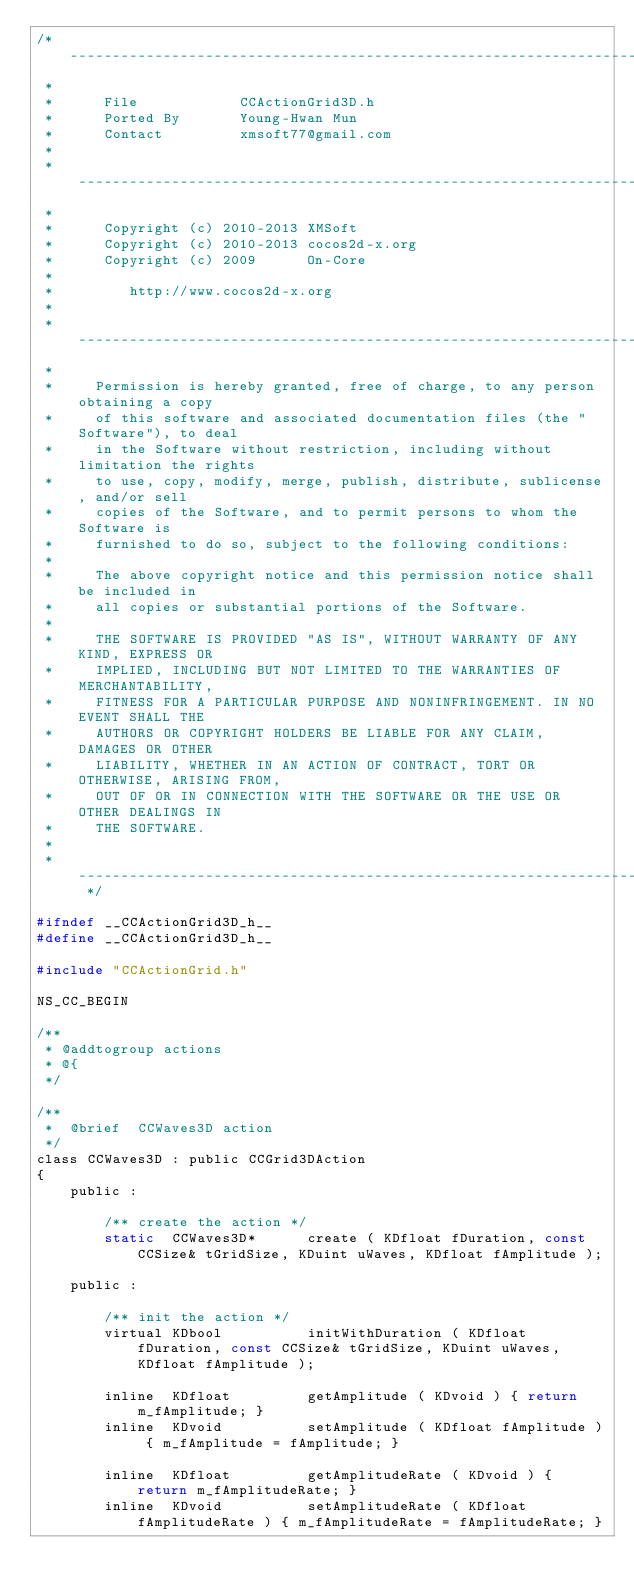Convert code to text. <code><loc_0><loc_0><loc_500><loc_500><_C_>/* -----------------------------------------------------------------------------------
 *
 *      File            CCActionGrid3D.h
 *      Ported By       Young-Hwan Mun
 *      Contact         xmsoft77@gmail.com 
 * 
 * -----------------------------------------------------------------------------------
 *   
 *      Copyright (c) 2010-2013 XMSoft
 *      Copyright (c) 2010-2013 cocos2d-x.org
 *      Copyright (c) 2009      On-Core
 *
 *         http://www.cocos2d-x.org      
 *
 * -----------------------------------------------------------------------------------
 * 
 *     Permission is hereby granted, free of charge, to any person obtaining a copy
 *     of this software and associated documentation files (the "Software"), to deal
 *     in the Software without restriction, including without limitation the rights
 *     to use, copy, modify, merge, publish, distribute, sublicense, and/or sell
 *     copies of the Software, and to permit persons to whom the Software is
 *     furnished to do so, subject to the following conditions:
 *
 *     The above copyright notice and this permission notice shall be included in
 *     all copies or substantial portions of the Software.
 *     
 *     THE SOFTWARE IS PROVIDED "AS IS", WITHOUT WARRANTY OF ANY KIND, EXPRESS OR
 *     IMPLIED, INCLUDING BUT NOT LIMITED TO THE WARRANTIES OF MERCHANTABILITY,
 *     FITNESS FOR A PARTICULAR PURPOSE AND NONINFRINGEMENT. IN NO EVENT SHALL THE
 *     AUTHORS OR COPYRIGHT HOLDERS BE LIABLE FOR ANY CLAIM, DAMAGES OR OTHER
 *     LIABILITY, WHETHER IN AN ACTION OF CONTRACT, TORT OR OTHERWISE, ARISING FROM,
 *     OUT OF OR IN CONNECTION WITH THE SOFTWARE OR THE USE OR OTHER DEALINGS IN
 *     THE SOFTWARE.
 *
 * ----------------------------------------------------------------------------------- */ 

#ifndef __CCActionGrid3D_h__
#define __CCActionGrid3D_h__

#include "CCActionGrid.h"

NS_CC_BEGIN
    
/**
 * @addtogroup actions
 * @{
 */

/** 
 *	@brief	CCWaves3D action 
 */
class CCWaves3D : public CCGrid3DAction
{
	public :

		/** create the action */
		static  CCWaves3D*		create ( KDfloat fDuration, const CCSize& tGridSize, KDuint uWaves, KDfloat fAmplitude );

	public :

		/** init the action */
		virtual KDbool			initWithDuration ( KDfloat fDuration, const CCSize& tGridSize, KDuint uWaves, KDfloat fAmplitude );

		inline  KDfloat			getAmplitude ( KDvoid ) { return m_fAmplitude; }
		inline  KDvoid			setAmplitude ( KDfloat fAmplitude ) { m_fAmplitude = fAmplitude; }

		inline  KDfloat			getAmplitudeRate ( KDvoid ) { return m_fAmplitudeRate; }
		inline  KDvoid			setAmplitudeRate ( KDfloat fAmplitudeRate ) { m_fAmplitudeRate = fAmplitudeRate; }
</code> 